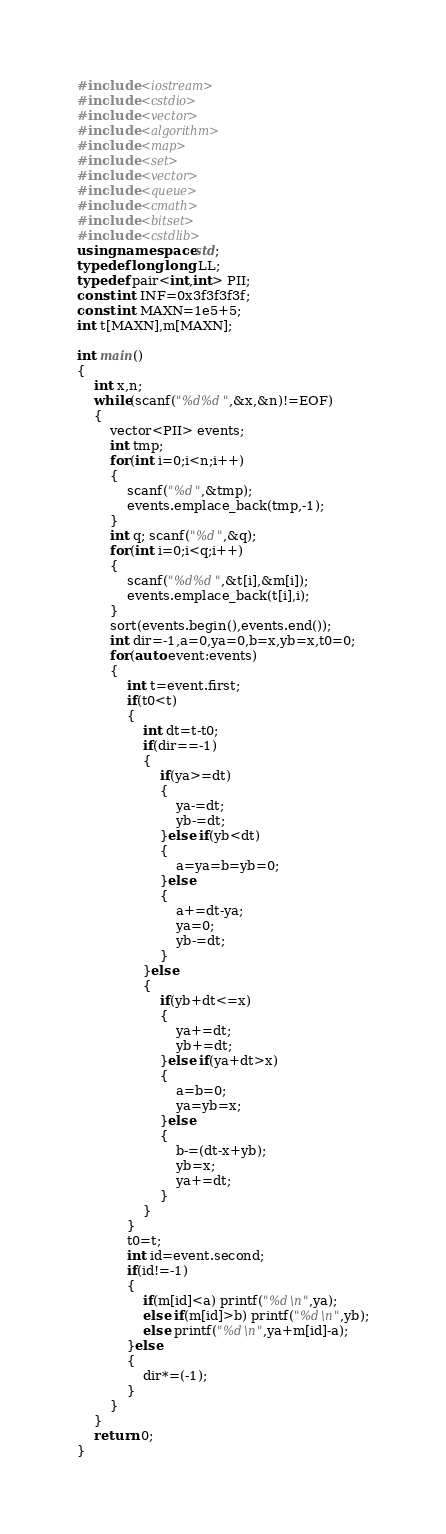<code> <loc_0><loc_0><loc_500><loc_500><_C++_>#include <iostream>
#include <cstdio>
#include <vector>
#include <algorithm>
#include <map>
#include <set>
#include <vector>
#include <queue>
#include <cmath>
#include <bitset>
#include <cstdlib>
using namespace std;
typedef long long LL;
typedef pair<int,int> PII;
const int INF=0x3f3f3f3f;
const int MAXN=1e5+5;
int t[MAXN],m[MAXN];

int main()
{
    int x,n;
    while(scanf("%d%d",&x,&n)!=EOF)
    {
        vector<PII> events;
        int tmp;
        for(int i=0;i<n;i++)
        {
            scanf("%d",&tmp);
            events.emplace_back(tmp,-1);
        }
        int q; scanf("%d",&q);
        for(int i=0;i<q;i++)
        {
            scanf("%d%d",&t[i],&m[i]);
            events.emplace_back(t[i],i);
        }
        sort(events.begin(),events.end());
        int dir=-1,a=0,ya=0,b=x,yb=x,t0=0;
        for(auto event:events)
        {
            int t=event.first;
            if(t0<t)
            {
                int dt=t-t0;
                if(dir==-1)
                {
                    if(ya>=dt)
                    {
                        ya-=dt;
                        yb-=dt;
                    }else if(yb<dt)
                    {
                        a=ya=b=yb=0;
                    }else
                    {
                        a+=dt-ya;
                        ya=0;
                        yb-=dt;
                    }
                }else
                {
                    if(yb+dt<=x)
                    {
                        ya+=dt;
                        yb+=dt;
                    }else if(ya+dt>x)
                    {
                        a=b=0;
                        ya=yb=x;
                    }else
                    {
                        b-=(dt-x+yb);
                        yb=x;
                        ya+=dt;
                    }
                }
            }
            t0=t;
            int id=event.second;
            if(id!=-1)
            {
                if(m[id]<a) printf("%d\n",ya);
                else if(m[id]>b) printf("%d\n",yb);
                else printf("%d\n",ya+m[id]-a);
            }else
            {
                dir*=(-1);
            }
        }
    }
    return 0;
}</code> 